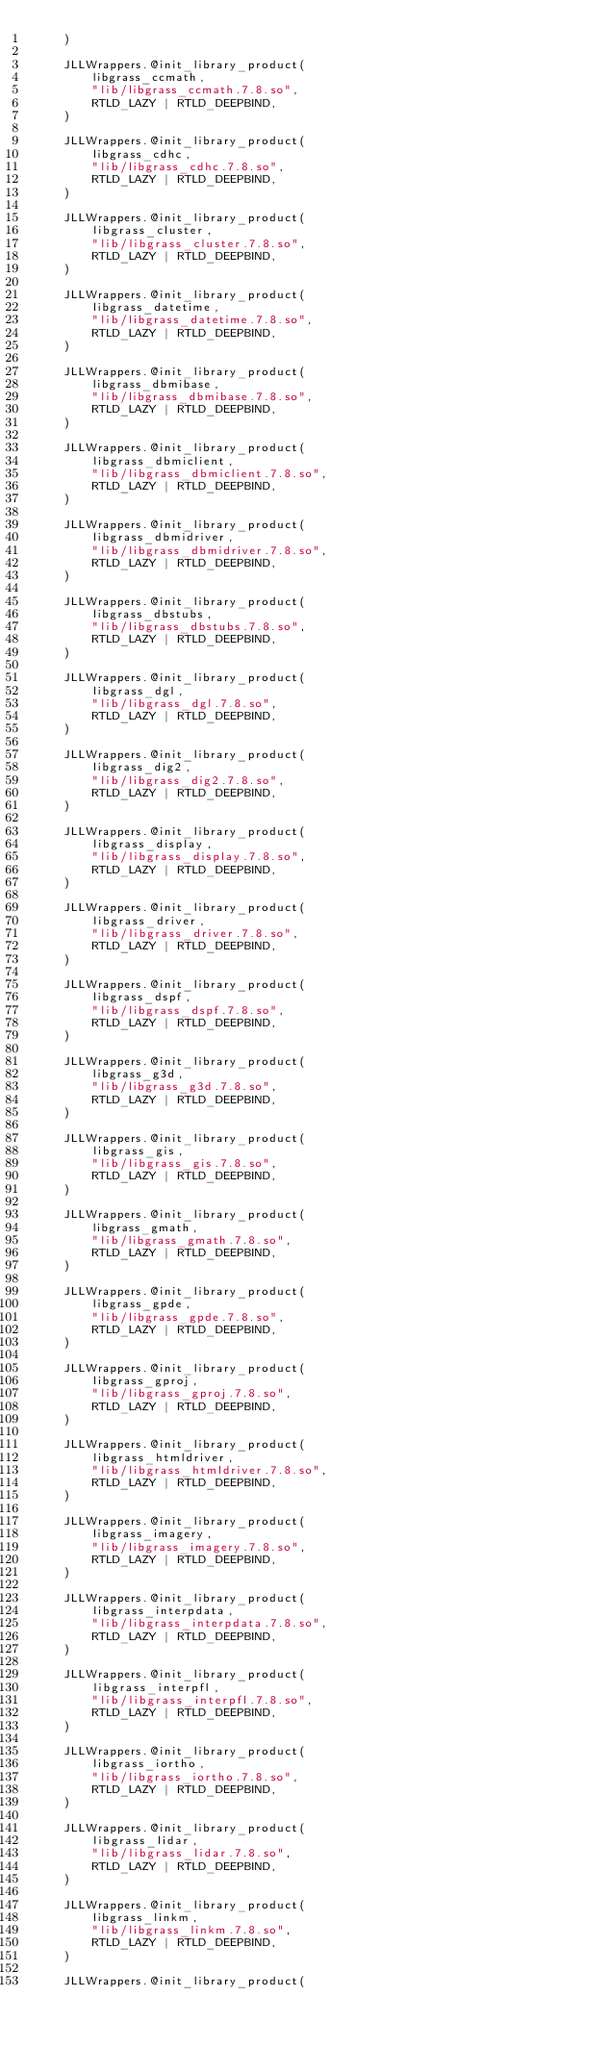<code> <loc_0><loc_0><loc_500><loc_500><_Julia_>    )

    JLLWrappers.@init_library_product(
        libgrass_ccmath,
        "lib/libgrass_ccmath.7.8.so",
        RTLD_LAZY | RTLD_DEEPBIND,
    )

    JLLWrappers.@init_library_product(
        libgrass_cdhc,
        "lib/libgrass_cdhc.7.8.so",
        RTLD_LAZY | RTLD_DEEPBIND,
    )

    JLLWrappers.@init_library_product(
        libgrass_cluster,
        "lib/libgrass_cluster.7.8.so",
        RTLD_LAZY | RTLD_DEEPBIND,
    )

    JLLWrappers.@init_library_product(
        libgrass_datetime,
        "lib/libgrass_datetime.7.8.so",
        RTLD_LAZY | RTLD_DEEPBIND,
    )

    JLLWrappers.@init_library_product(
        libgrass_dbmibase,
        "lib/libgrass_dbmibase.7.8.so",
        RTLD_LAZY | RTLD_DEEPBIND,
    )

    JLLWrappers.@init_library_product(
        libgrass_dbmiclient,
        "lib/libgrass_dbmiclient.7.8.so",
        RTLD_LAZY | RTLD_DEEPBIND,
    )

    JLLWrappers.@init_library_product(
        libgrass_dbmidriver,
        "lib/libgrass_dbmidriver.7.8.so",
        RTLD_LAZY | RTLD_DEEPBIND,
    )

    JLLWrappers.@init_library_product(
        libgrass_dbstubs,
        "lib/libgrass_dbstubs.7.8.so",
        RTLD_LAZY | RTLD_DEEPBIND,
    )

    JLLWrappers.@init_library_product(
        libgrass_dgl,
        "lib/libgrass_dgl.7.8.so",
        RTLD_LAZY | RTLD_DEEPBIND,
    )

    JLLWrappers.@init_library_product(
        libgrass_dig2,
        "lib/libgrass_dig2.7.8.so",
        RTLD_LAZY | RTLD_DEEPBIND,
    )

    JLLWrappers.@init_library_product(
        libgrass_display,
        "lib/libgrass_display.7.8.so",
        RTLD_LAZY | RTLD_DEEPBIND,
    )

    JLLWrappers.@init_library_product(
        libgrass_driver,
        "lib/libgrass_driver.7.8.so",
        RTLD_LAZY | RTLD_DEEPBIND,
    )

    JLLWrappers.@init_library_product(
        libgrass_dspf,
        "lib/libgrass_dspf.7.8.so",
        RTLD_LAZY | RTLD_DEEPBIND,
    )

    JLLWrappers.@init_library_product(
        libgrass_g3d,
        "lib/libgrass_g3d.7.8.so",
        RTLD_LAZY | RTLD_DEEPBIND,
    )

    JLLWrappers.@init_library_product(
        libgrass_gis,
        "lib/libgrass_gis.7.8.so",
        RTLD_LAZY | RTLD_DEEPBIND,
    )

    JLLWrappers.@init_library_product(
        libgrass_gmath,
        "lib/libgrass_gmath.7.8.so",
        RTLD_LAZY | RTLD_DEEPBIND,
    )

    JLLWrappers.@init_library_product(
        libgrass_gpde,
        "lib/libgrass_gpde.7.8.so",
        RTLD_LAZY | RTLD_DEEPBIND,
    )

    JLLWrappers.@init_library_product(
        libgrass_gproj,
        "lib/libgrass_gproj.7.8.so",
        RTLD_LAZY | RTLD_DEEPBIND,
    )

    JLLWrappers.@init_library_product(
        libgrass_htmldriver,
        "lib/libgrass_htmldriver.7.8.so",
        RTLD_LAZY | RTLD_DEEPBIND,
    )

    JLLWrappers.@init_library_product(
        libgrass_imagery,
        "lib/libgrass_imagery.7.8.so",
        RTLD_LAZY | RTLD_DEEPBIND,
    )

    JLLWrappers.@init_library_product(
        libgrass_interpdata,
        "lib/libgrass_interpdata.7.8.so",
        RTLD_LAZY | RTLD_DEEPBIND,
    )

    JLLWrappers.@init_library_product(
        libgrass_interpfl,
        "lib/libgrass_interpfl.7.8.so",
        RTLD_LAZY | RTLD_DEEPBIND,
    )

    JLLWrappers.@init_library_product(
        libgrass_iortho,
        "lib/libgrass_iortho.7.8.so",
        RTLD_LAZY | RTLD_DEEPBIND,
    )

    JLLWrappers.@init_library_product(
        libgrass_lidar,
        "lib/libgrass_lidar.7.8.so",
        RTLD_LAZY | RTLD_DEEPBIND,
    )

    JLLWrappers.@init_library_product(
        libgrass_linkm,
        "lib/libgrass_linkm.7.8.so",
        RTLD_LAZY | RTLD_DEEPBIND,
    )

    JLLWrappers.@init_library_product(</code> 